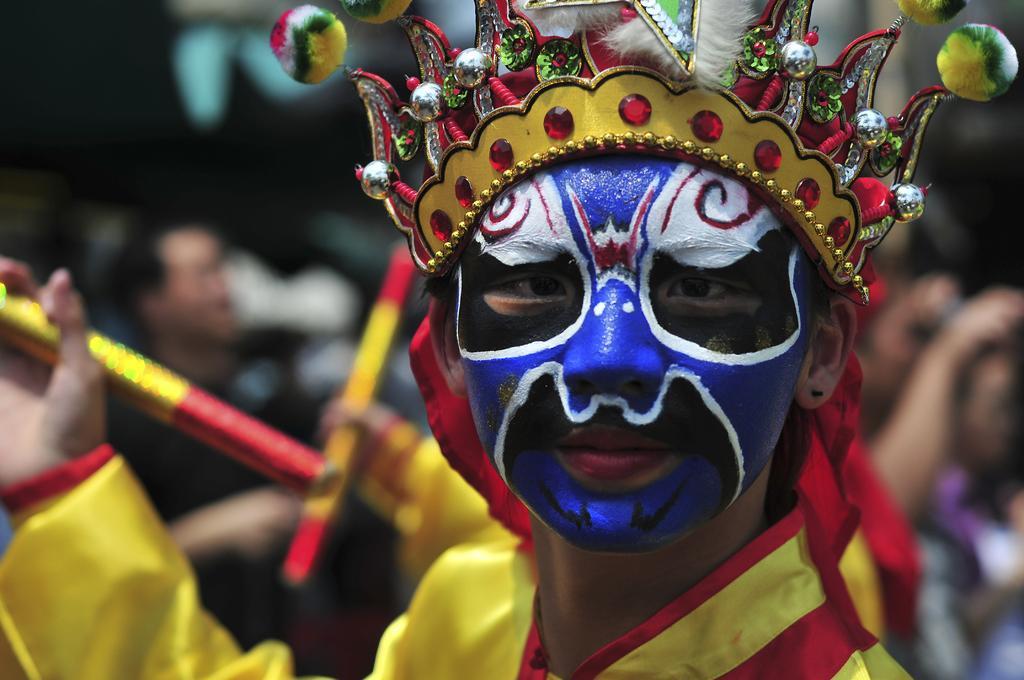Please provide a concise description of this image. In this image I can see the person and the person is wearing yellow color dress and I can see the painting on the person's face and I can see the blurred background. 